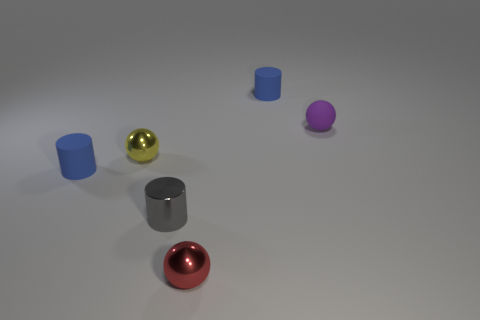There is a tiny blue cylinder that is behind the small matte sphere; what material is it? While it's challenging to ascertain material properties from a visual alone, the tiny blue cylinder appears to have similar characteristics to the matte surfaces of the other objects, indicating it may be made of a material with a non-glossy finish such as painted metal or plastic. 